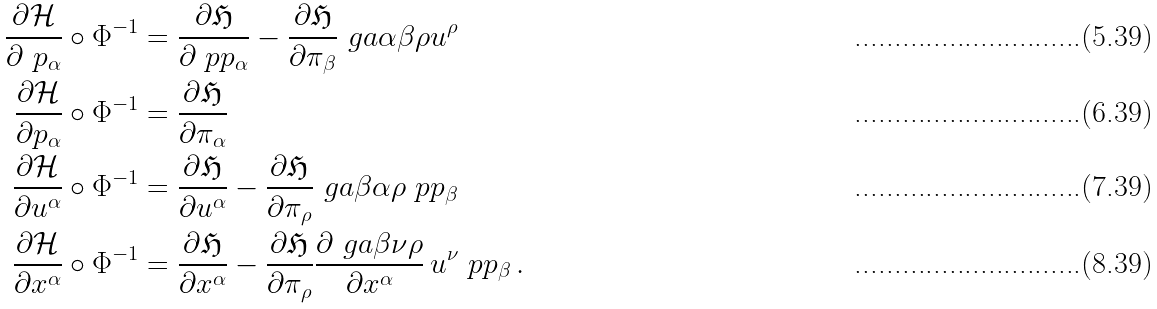<formula> <loc_0><loc_0><loc_500><loc_500>\frac { \partial \mathcal { H } } { \partial \ p _ { \alpha } } \circ \Phi ^ { - 1 } & = \frac { \partial \mathfrak H } { \partial \ p p _ { \alpha } } - \frac { \partial \mathfrak H } { \partial \pi _ { \beta } } \ g a \alpha \beta \rho u ^ { \rho } \\ \frac { \partial \mathcal { H } } { \partial p _ { \alpha } } \circ \Phi ^ { - 1 } & = \frac { \partial \mathfrak H } { \partial \pi _ { \alpha } } \\ \frac { \partial \mathcal { H } } { \partial u ^ { \alpha } } \circ \Phi ^ { - 1 } & = \frac { \partial \mathfrak H } { \partial u ^ { \alpha } } - \frac { \partial \mathfrak H } { \partial \pi _ { \rho } } \ g a \beta \alpha \rho \ p p _ { \beta } \\ \frac { \partial \mathcal { H } } { \partial x ^ { \alpha } } \circ \Phi ^ { - 1 } & = \frac { \partial \mathfrak H } { \partial x ^ { \alpha } } - \frac { \partial \mathfrak H } { \partial \pi _ { \rho } } \frac { \partial \ g a \beta \nu \rho } { \partial x ^ { \alpha } } \, u ^ { \nu } \ p p _ { \beta } \, .</formula> 